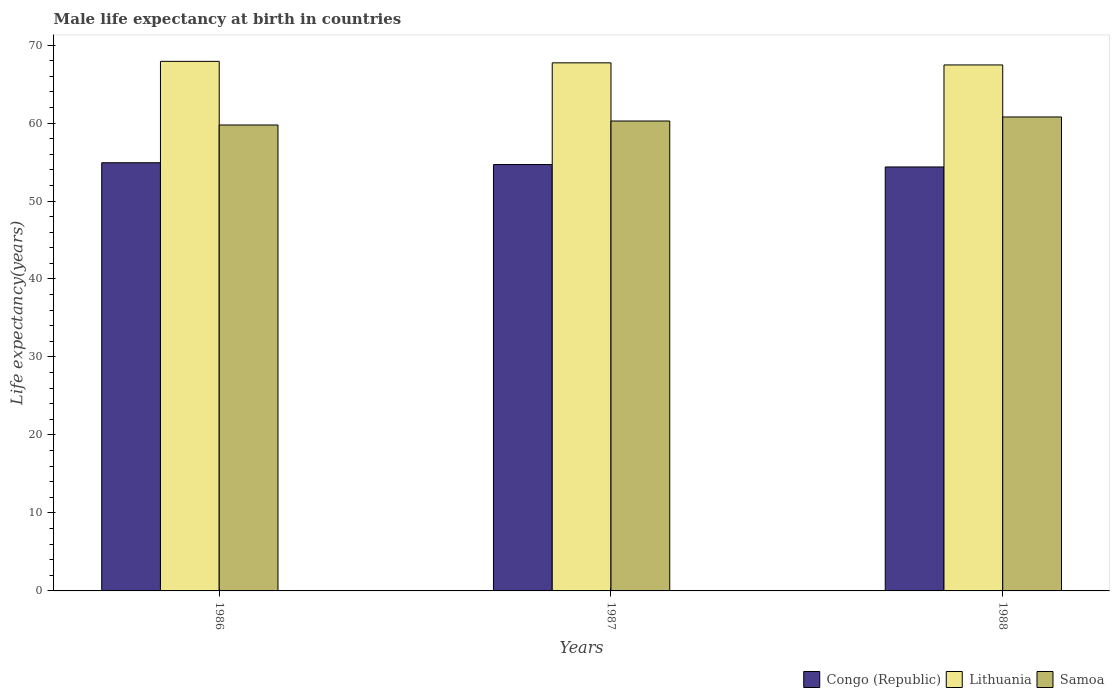Are the number of bars on each tick of the X-axis equal?
Offer a very short reply. Yes. How many bars are there on the 3rd tick from the left?
Keep it short and to the point. 3. What is the label of the 2nd group of bars from the left?
Keep it short and to the point. 1987. In how many cases, is the number of bars for a given year not equal to the number of legend labels?
Keep it short and to the point. 0. What is the male life expectancy at birth in Lithuania in 1986?
Make the answer very short. 67.91. Across all years, what is the maximum male life expectancy at birth in Congo (Republic)?
Your answer should be compact. 54.91. Across all years, what is the minimum male life expectancy at birth in Samoa?
Provide a succinct answer. 59.75. In which year was the male life expectancy at birth in Samoa maximum?
Your answer should be compact. 1988. In which year was the male life expectancy at birth in Lithuania minimum?
Offer a terse response. 1988. What is the total male life expectancy at birth in Congo (Republic) in the graph?
Your answer should be compact. 163.95. What is the difference between the male life expectancy at birth in Samoa in 1986 and that in 1988?
Your response must be concise. -1.03. What is the difference between the male life expectancy at birth in Lithuania in 1986 and the male life expectancy at birth in Congo (Republic) in 1988?
Your answer should be very brief. 13.54. What is the average male life expectancy at birth in Samoa per year?
Your answer should be compact. 60.26. In the year 1987, what is the difference between the male life expectancy at birth in Lithuania and male life expectancy at birth in Congo (Republic)?
Ensure brevity in your answer.  13.05. In how many years, is the male life expectancy at birth in Lithuania greater than 44 years?
Your response must be concise. 3. What is the ratio of the male life expectancy at birth in Samoa in 1987 to that in 1988?
Keep it short and to the point. 0.99. Is the difference between the male life expectancy at birth in Lithuania in 1986 and 1988 greater than the difference between the male life expectancy at birth in Congo (Republic) in 1986 and 1988?
Keep it short and to the point. No. What is the difference between the highest and the second highest male life expectancy at birth in Congo (Republic)?
Your response must be concise. 0.23. What is the difference between the highest and the lowest male life expectancy at birth in Samoa?
Your answer should be compact. 1.03. In how many years, is the male life expectancy at birth in Samoa greater than the average male life expectancy at birth in Samoa taken over all years?
Your answer should be very brief. 1. What does the 1st bar from the left in 1987 represents?
Ensure brevity in your answer.  Congo (Republic). What does the 1st bar from the right in 1986 represents?
Offer a terse response. Samoa. Is it the case that in every year, the sum of the male life expectancy at birth in Lithuania and male life expectancy at birth in Congo (Republic) is greater than the male life expectancy at birth in Samoa?
Your answer should be very brief. Yes. How many bars are there?
Make the answer very short. 9. Are all the bars in the graph horizontal?
Keep it short and to the point. No. What is the difference between two consecutive major ticks on the Y-axis?
Ensure brevity in your answer.  10. Are the values on the major ticks of Y-axis written in scientific E-notation?
Offer a very short reply. No. Does the graph contain any zero values?
Provide a short and direct response. No. Does the graph contain grids?
Provide a short and direct response. No. Where does the legend appear in the graph?
Your answer should be compact. Bottom right. How many legend labels are there?
Make the answer very short. 3. What is the title of the graph?
Give a very brief answer. Male life expectancy at birth in countries. What is the label or title of the X-axis?
Your answer should be very brief. Years. What is the label or title of the Y-axis?
Ensure brevity in your answer.  Life expectancy(years). What is the Life expectancy(years) of Congo (Republic) in 1986?
Ensure brevity in your answer.  54.91. What is the Life expectancy(years) of Lithuania in 1986?
Your answer should be very brief. 67.91. What is the Life expectancy(years) in Samoa in 1986?
Provide a short and direct response. 59.75. What is the Life expectancy(years) of Congo (Republic) in 1987?
Give a very brief answer. 54.67. What is the Life expectancy(years) of Lithuania in 1987?
Provide a succinct answer. 67.72. What is the Life expectancy(years) of Samoa in 1987?
Ensure brevity in your answer.  60.26. What is the Life expectancy(years) in Congo (Republic) in 1988?
Make the answer very short. 54.37. What is the Life expectancy(years) of Lithuania in 1988?
Provide a succinct answer. 67.45. What is the Life expectancy(years) in Samoa in 1988?
Your answer should be compact. 60.78. Across all years, what is the maximum Life expectancy(years) of Congo (Republic)?
Keep it short and to the point. 54.91. Across all years, what is the maximum Life expectancy(years) in Lithuania?
Offer a terse response. 67.91. Across all years, what is the maximum Life expectancy(years) of Samoa?
Keep it short and to the point. 60.78. Across all years, what is the minimum Life expectancy(years) in Congo (Republic)?
Make the answer very short. 54.37. Across all years, what is the minimum Life expectancy(years) of Lithuania?
Give a very brief answer. 67.45. Across all years, what is the minimum Life expectancy(years) of Samoa?
Your answer should be compact. 59.75. What is the total Life expectancy(years) of Congo (Republic) in the graph?
Offer a very short reply. 163.95. What is the total Life expectancy(years) of Lithuania in the graph?
Offer a terse response. 203.08. What is the total Life expectancy(years) of Samoa in the graph?
Your response must be concise. 180.79. What is the difference between the Life expectancy(years) in Congo (Republic) in 1986 and that in 1987?
Ensure brevity in your answer.  0.23. What is the difference between the Life expectancy(years) of Lithuania in 1986 and that in 1987?
Offer a terse response. 0.19. What is the difference between the Life expectancy(years) in Samoa in 1986 and that in 1987?
Your answer should be compact. -0.51. What is the difference between the Life expectancy(years) of Congo (Republic) in 1986 and that in 1988?
Your response must be concise. 0.54. What is the difference between the Life expectancy(years) in Lithuania in 1986 and that in 1988?
Provide a succinct answer. 0.46. What is the difference between the Life expectancy(years) of Samoa in 1986 and that in 1988?
Provide a short and direct response. -1.03. What is the difference between the Life expectancy(years) of Congo (Republic) in 1987 and that in 1988?
Provide a short and direct response. 0.31. What is the difference between the Life expectancy(years) in Lithuania in 1987 and that in 1988?
Keep it short and to the point. 0.27. What is the difference between the Life expectancy(years) in Samoa in 1987 and that in 1988?
Your answer should be very brief. -0.52. What is the difference between the Life expectancy(years) in Congo (Republic) in 1986 and the Life expectancy(years) in Lithuania in 1987?
Your answer should be very brief. -12.81. What is the difference between the Life expectancy(years) of Congo (Republic) in 1986 and the Life expectancy(years) of Samoa in 1987?
Keep it short and to the point. -5.35. What is the difference between the Life expectancy(years) in Lithuania in 1986 and the Life expectancy(years) in Samoa in 1987?
Provide a short and direct response. 7.65. What is the difference between the Life expectancy(years) in Congo (Republic) in 1986 and the Life expectancy(years) in Lithuania in 1988?
Keep it short and to the point. -12.54. What is the difference between the Life expectancy(years) in Congo (Republic) in 1986 and the Life expectancy(years) in Samoa in 1988?
Provide a succinct answer. -5.87. What is the difference between the Life expectancy(years) of Lithuania in 1986 and the Life expectancy(years) of Samoa in 1988?
Your answer should be compact. 7.13. What is the difference between the Life expectancy(years) in Congo (Republic) in 1987 and the Life expectancy(years) in Lithuania in 1988?
Provide a short and direct response. -12.78. What is the difference between the Life expectancy(years) in Congo (Republic) in 1987 and the Life expectancy(years) in Samoa in 1988?
Ensure brevity in your answer.  -6.1. What is the difference between the Life expectancy(years) in Lithuania in 1987 and the Life expectancy(years) in Samoa in 1988?
Your response must be concise. 6.94. What is the average Life expectancy(years) in Congo (Republic) per year?
Keep it short and to the point. 54.65. What is the average Life expectancy(years) of Lithuania per year?
Your response must be concise. 67.69. What is the average Life expectancy(years) of Samoa per year?
Your response must be concise. 60.26. In the year 1986, what is the difference between the Life expectancy(years) in Congo (Republic) and Life expectancy(years) in Lithuania?
Your answer should be compact. -13. In the year 1986, what is the difference between the Life expectancy(years) in Congo (Republic) and Life expectancy(years) in Samoa?
Make the answer very short. -4.84. In the year 1986, what is the difference between the Life expectancy(years) of Lithuania and Life expectancy(years) of Samoa?
Provide a short and direct response. 8.16. In the year 1987, what is the difference between the Life expectancy(years) of Congo (Republic) and Life expectancy(years) of Lithuania?
Ensure brevity in your answer.  -13.04. In the year 1987, what is the difference between the Life expectancy(years) of Congo (Republic) and Life expectancy(years) of Samoa?
Your response must be concise. -5.58. In the year 1987, what is the difference between the Life expectancy(years) of Lithuania and Life expectancy(years) of Samoa?
Provide a short and direct response. 7.46. In the year 1988, what is the difference between the Life expectancy(years) of Congo (Republic) and Life expectancy(years) of Lithuania?
Keep it short and to the point. -13.08. In the year 1988, what is the difference between the Life expectancy(years) of Congo (Republic) and Life expectancy(years) of Samoa?
Ensure brevity in your answer.  -6.41. In the year 1988, what is the difference between the Life expectancy(years) of Lithuania and Life expectancy(years) of Samoa?
Offer a terse response. 6.67. What is the ratio of the Life expectancy(years) of Lithuania in 1986 to that in 1987?
Give a very brief answer. 1. What is the ratio of the Life expectancy(years) in Lithuania in 1986 to that in 1988?
Give a very brief answer. 1.01. What is the ratio of the Life expectancy(years) in Samoa in 1986 to that in 1988?
Provide a short and direct response. 0.98. What is the ratio of the Life expectancy(years) in Congo (Republic) in 1987 to that in 1988?
Offer a very short reply. 1.01. What is the ratio of the Life expectancy(years) of Samoa in 1987 to that in 1988?
Provide a succinct answer. 0.99. What is the difference between the highest and the second highest Life expectancy(years) in Congo (Republic)?
Give a very brief answer. 0.23. What is the difference between the highest and the second highest Life expectancy(years) of Lithuania?
Provide a short and direct response. 0.19. What is the difference between the highest and the second highest Life expectancy(years) in Samoa?
Your response must be concise. 0.52. What is the difference between the highest and the lowest Life expectancy(years) of Congo (Republic)?
Your answer should be compact. 0.54. What is the difference between the highest and the lowest Life expectancy(years) of Lithuania?
Provide a succinct answer. 0.46. What is the difference between the highest and the lowest Life expectancy(years) of Samoa?
Make the answer very short. 1.03. 